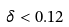Convert formula to latex. <formula><loc_0><loc_0><loc_500><loc_500>\delta < 0 . 1 2</formula> 